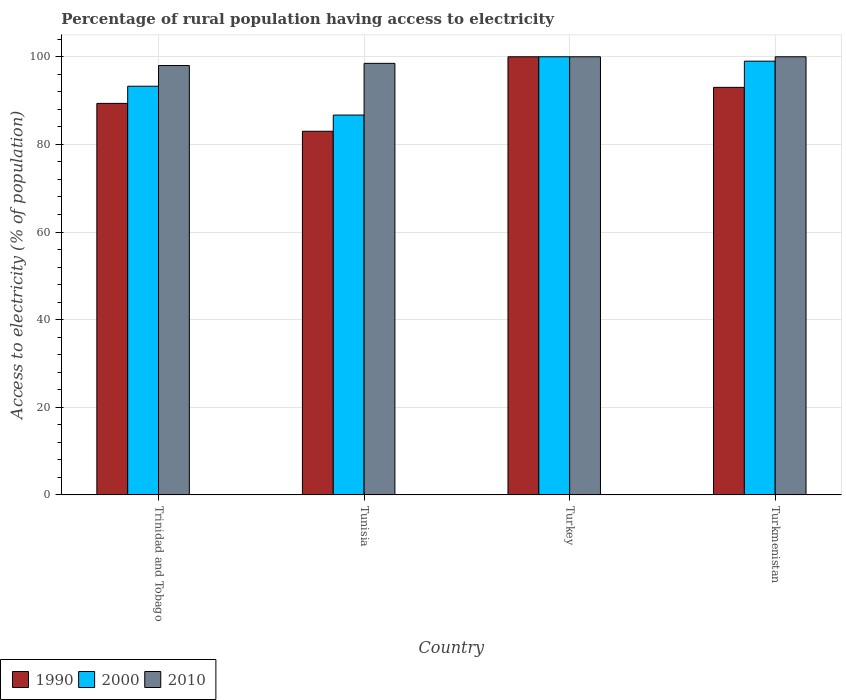How many different coloured bars are there?
Keep it short and to the point. 3. Are the number of bars on each tick of the X-axis equal?
Your response must be concise. Yes. What is the label of the 1st group of bars from the left?
Provide a short and direct response. Trinidad and Tobago. In how many cases, is the number of bars for a given country not equal to the number of legend labels?
Ensure brevity in your answer.  0. Across all countries, what is the minimum percentage of rural population having access to electricity in 2010?
Ensure brevity in your answer.  98. In which country was the percentage of rural population having access to electricity in 1990 maximum?
Your answer should be very brief. Turkey. In which country was the percentage of rural population having access to electricity in 2000 minimum?
Provide a succinct answer. Tunisia. What is the total percentage of rural population having access to electricity in 1990 in the graph?
Provide a short and direct response. 365.38. What is the difference between the percentage of rural population having access to electricity in 2000 in Tunisia and the percentage of rural population having access to electricity in 2010 in Turkey?
Your answer should be very brief. -13.3. What is the average percentage of rural population having access to electricity in 2000 per country?
Provide a succinct answer. 94.75. What is the difference between the percentage of rural population having access to electricity of/in 2000 and percentage of rural population having access to electricity of/in 2010 in Tunisia?
Make the answer very short. -11.8. In how many countries, is the percentage of rural population having access to electricity in 2000 greater than 80 %?
Offer a very short reply. 4. What is the ratio of the percentage of rural population having access to electricity in 2000 in Tunisia to that in Turkey?
Your response must be concise. 0.87. Is the percentage of rural population having access to electricity in 2010 in Tunisia less than that in Turkmenistan?
Give a very brief answer. Yes. Is the difference between the percentage of rural population having access to electricity in 2000 in Turkey and Turkmenistan greater than the difference between the percentage of rural population having access to electricity in 2010 in Turkey and Turkmenistan?
Offer a terse response. Yes. What is the difference between the highest and the lowest percentage of rural population having access to electricity in 1990?
Provide a succinct answer. 17. Is the sum of the percentage of rural population having access to electricity in 2010 in Trinidad and Tobago and Turkmenistan greater than the maximum percentage of rural population having access to electricity in 1990 across all countries?
Your response must be concise. Yes. Is it the case that in every country, the sum of the percentage of rural population having access to electricity in 2010 and percentage of rural population having access to electricity in 1990 is greater than the percentage of rural population having access to electricity in 2000?
Offer a very short reply. Yes. Are the values on the major ticks of Y-axis written in scientific E-notation?
Give a very brief answer. No. Does the graph contain any zero values?
Provide a succinct answer. No. Where does the legend appear in the graph?
Offer a terse response. Bottom left. How many legend labels are there?
Provide a short and direct response. 3. How are the legend labels stacked?
Offer a very short reply. Horizontal. What is the title of the graph?
Your response must be concise. Percentage of rural population having access to electricity. Does "2006" appear as one of the legend labels in the graph?
Provide a succinct answer. No. What is the label or title of the X-axis?
Your answer should be compact. Country. What is the label or title of the Y-axis?
Your answer should be compact. Access to electricity (% of population). What is the Access to electricity (% of population) in 1990 in Trinidad and Tobago?
Provide a succinct answer. 89.36. What is the Access to electricity (% of population) of 2000 in Trinidad and Tobago?
Offer a very short reply. 93.28. What is the Access to electricity (% of population) in 2010 in Trinidad and Tobago?
Keep it short and to the point. 98. What is the Access to electricity (% of population) of 2000 in Tunisia?
Provide a short and direct response. 86.7. What is the Access to electricity (% of population) of 2010 in Tunisia?
Ensure brevity in your answer.  98.5. What is the Access to electricity (% of population) in 1990 in Turkey?
Ensure brevity in your answer.  100. What is the Access to electricity (% of population) of 2010 in Turkey?
Keep it short and to the point. 100. What is the Access to electricity (% of population) in 1990 in Turkmenistan?
Your response must be concise. 93.02. What is the Access to electricity (% of population) of 2010 in Turkmenistan?
Give a very brief answer. 100. Across all countries, what is the maximum Access to electricity (% of population) in 2000?
Make the answer very short. 100. Across all countries, what is the minimum Access to electricity (% of population) of 2000?
Make the answer very short. 86.7. Across all countries, what is the minimum Access to electricity (% of population) in 2010?
Provide a succinct answer. 98. What is the total Access to electricity (% of population) of 1990 in the graph?
Offer a very short reply. 365.38. What is the total Access to electricity (% of population) in 2000 in the graph?
Your response must be concise. 378.98. What is the total Access to electricity (% of population) of 2010 in the graph?
Keep it short and to the point. 396.5. What is the difference between the Access to electricity (% of population) of 1990 in Trinidad and Tobago and that in Tunisia?
Give a very brief answer. 6.36. What is the difference between the Access to electricity (% of population) of 2000 in Trinidad and Tobago and that in Tunisia?
Make the answer very short. 6.58. What is the difference between the Access to electricity (% of population) of 2010 in Trinidad and Tobago and that in Tunisia?
Give a very brief answer. -0.5. What is the difference between the Access to electricity (% of population) of 1990 in Trinidad and Tobago and that in Turkey?
Your answer should be very brief. -10.64. What is the difference between the Access to electricity (% of population) of 2000 in Trinidad and Tobago and that in Turkey?
Your response must be concise. -6.72. What is the difference between the Access to electricity (% of population) in 1990 in Trinidad and Tobago and that in Turkmenistan?
Your response must be concise. -3.66. What is the difference between the Access to electricity (% of population) of 2000 in Trinidad and Tobago and that in Turkmenistan?
Provide a succinct answer. -5.72. What is the difference between the Access to electricity (% of population) of 2010 in Trinidad and Tobago and that in Turkmenistan?
Offer a terse response. -2. What is the difference between the Access to electricity (% of population) of 1990 in Tunisia and that in Turkey?
Your response must be concise. -17. What is the difference between the Access to electricity (% of population) of 1990 in Tunisia and that in Turkmenistan?
Provide a succinct answer. -10.02. What is the difference between the Access to electricity (% of population) of 2010 in Tunisia and that in Turkmenistan?
Ensure brevity in your answer.  -1.5. What is the difference between the Access to electricity (% of population) of 1990 in Turkey and that in Turkmenistan?
Offer a terse response. 6.98. What is the difference between the Access to electricity (% of population) of 1990 in Trinidad and Tobago and the Access to electricity (% of population) of 2000 in Tunisia?
Keep it short and to the point. 2.66. What is the difference between the Access to electricity (% of population) of 1990 in Trinidad and Tobago and the Access to electricity (% of population) of 2010 in Tunisia?
Provide a succinct answer. -9.14. What is the difference between the Access to electricity (% of population) of 2000 in Trinidad and Tobago and the Access to electricity (% of population) of 2010 in Tunisia?
Offer a very short reply. -5.22. What is the difference between the Access to electricity (% of population) in 1990 in Trinidad and Tobago and the Access to electricity (% of population) in 2000 in Turkey?
Your response must be concise. -10.64. What is the difference between the Access to electricity (% of population) in 1990 in Trinidad and Tobago and the Access to electricity (% of population) in 2010 in Turkey?
Offer a terse response. -10.64. What is the difference between the Access to electricity (% of population) of 2000 in Trinidad and Tobago and the Access to electricity (% of population) of 2010 in Turkey?
Give a very brief answer. -6.72. What is the difference between the Access to electricity (% of population) of 1990 in Trinidad and Tobago and the Access to electricity (% of population) of 2000 in Turkmenistan?
Offer a terse response. -9.64. What is the difference between the Access to electricity (% of population) in 1990 in Trinidad and Tobago and the Access to electricity (% of population) in 2010 in Turkmenistan?
Offer a terse response. -10.64. What is the difference between the Access to electricity (% of population) in 2000 in Trinidad and Tobago and the Access to electricity (% of population) in 2010 in Turkmenistan?
Give a very brief answer. -6.72. What is the difference between the Access to electricity (% of population) in 1990 in Tunisia and the Access to electricity (% of population) in 2000 in Turkey?
Provide a short and direct response. -17. What is the difference between the Access to electricity (% of population) of 1990 in Tunisia and the Access to electricity (% of population) of 2010 in Turkey?
Provide a short and direct response. -17. What is the difference between the Access to electricity (% of population) of 1990 in Tunisia and the Access to electricity (% of population) of 2000 in Turkmenistan?
Ensure brevity in your answer.  -16. What is the difference between the Access to electricity (% of population) in 1990 in Tunisia and the Access to electricity (% of population) in 2010 in Turkmenistan?
Provide a succinct answer. -17. What is the difference between the Access to electricity (% of population) in 2000 in Tunisia and the Access to electricity (% of population) in 2010 in Turkmenistan?
Keep it short and to the point. -13.3. What is the difference between the Access to electricity (% of population) in 1990 in Turkey and the Access to electricity (% of population) in 2010 in Turkmenistan?
Make the answer very short. 0. What is the difference between the Access to electricity (% of population) in 2000 in Turkey and the Access to electricity (% of population) in 2010 in Turkmenistan?
Offer a terse response. 0. What is the average Access to electricity (% of population) in 1990 per country?
Ensure brevity in your answer.  91.34. What is the average Access to electricity (% of population) of 2000 per country?
Provide a succinct answer. 94.75. What is the average Access to electricity (% of population) of 2010 per country?
Your answer should be very brief. 99.12. What is the difference between the Access to electricity (% of population) in 1990 and Access to electricity (% of population) in 2000 in Trinidad and Tobago?
Your response must be concise. -3.92. What is the difference between the Access to electricity (% of population) of 1990 and Access to electricity (% of population) of 2010 in Trinidad and Tobago?
Offer a terse response. -8.64. What is the difference between the Access to electricity (% of population) of 2000 and Access to electricity (% of population) of 2010 in Trinidad and Tobago?
Provide a short and direct response. -4.72. What is the difference between the Access to electricity (% of population) in 1990 and Access to electricity (% of population) in 2000 in Tunisia?
Ensure brevity in your answer.  -3.7. What is the difference between the Access to electricity (% of population) of 1990 and Access to electricity (% of population) of 2010 in Tunisia?
Your answer should be compact. -15.5. What is the difference between the Access to electricity (% of population) of 2000 and Access to electricity (% of population) of 2010 in Tunisia?
Your response must be concise. -11.8. What is the difference between the Access to electricity (% of population) in 1990 and Access to electricity (% of population) in 2010 in Turkey?
Provide a short and direct response. 0. What is the difference between the Access to electricity (% of population) in 2000 and Access to electricity (% of population) in 2010 in Turkey?
Provide a short and direct response. 0. What is the difference between the Access to electricity (% of population) in 1990 and Access to electricity (% of population) in 2000 in Turkmenistan?
Provide a succinct answer. -5.98. What is the difference between the Access to electricity (% of population) in 1990 and Access to electricity (% of population) in 2010 in Turkmenistan?
Make the answer very short. -6.98. What is the ratio of the Access to electricity (% of population) in 1990 in Trinidad and Tobago to that in Tunisia?
Offer a very short reply. 1.08. What is the ratio of the Access to electricity (% of population) of 2000 in Trinidad and Tobago to that in Tunisia?
Provide a succinct answer. 1.08. What is the ratio of the Access to electricity (% of population) of 1990 in Trinidad and Tobago to that in Turkey?
Your response must be concise. 0.89. What is the ratio of the Access to electricity (% of population) of 2000 in Trinidad and Tobago to that in Turkey?
Offer a very short reply. 0.93. What is the ratio of the Access to electricity (% of population) of 1990 in Trinidad and Tobago to that in Turkmenistan?
Keep it short and to the point. 0.96. What is the ratio of the Access to electricity (% of population) in 2000 in Trinidad and Tobago to that in Turkmenistan?
Provide a short and direct response. 0.94. What is the ratio of the Access to electricity (% of population) in 2010 in Trinidad and Tobago to that in Turkmenistan?
Make the answer very short. 0.98. What is the ratio of the Access to electricity (% of population) of 1990 in Tunisia to that in Turkey?
Make the answer very short. 0.83. What is the ratio of the Access to electricity (% of population) in 2000 in Tunisia to that in Turkey?
Your response must be concise. 0.87. What is the ratio of the Access to electricity (% of population) in 1990 in Tunisia to that in Turkmenistan?
Ensure brevity in your answer.  0.89. What is the ratio of the Access to electricity (% of population) in 2000 in Tunisia to that in Turkmenistan?
Make the answer very short. 0.88. What is the ratio of the Access to electricity (% of population) in 1990 in Turkey to that in Turkmenistan?
Make the answer very short. 1.07. What is the ratio of the Access to electricity (% of population) of 2000 in Turkey to that in Turkmenistan?
Keep it short and to the point. 1.01. What is the ratio of the Access to electricity (% of population) in 2010 in Turkey to that in Turkmenistan?
Your answer should be very brief. 1. What is the difference between the highest and the second highest Access to electricity (% of population) of 1990?
Provide a short and direct response. 6.98. What is the difference between the highest and the second highest Access to electricity (% of population) in 2000?
Provide a short and direct response. 1. What is the difference between the highest and the second highest Access to electricity (% of population) of 2010?
Your answer should be compact. 0. What is the difference between the highest and the lowest Access to electricity (% of population) of 2000?
Keep it short and to the point. 13.3. 